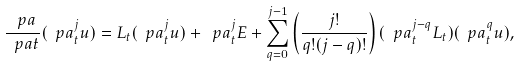<formula> <loc_0><loc_0><loc_500><loc_500>\frac { \ p a } { \ p a t } ( \ p a ^ { j } _ { t } u ) = L _ { t } ( \ p a ^ { j } _ { t } u ) + \ p a _ { t } ^ { j } E + \sum _ { q = 0 } ^ { j - 1 } \left ( \frac { j ! } { q ! ( j - q ) ! } \right ) ( \ p a _ { t } ^ { j - q } L _ { t } ) ( \ p a _ { t } ^ { q } u ) ,</formula> 